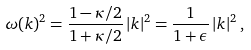<formula> <loc_0><loc_0><loc_500><loc_500>\omega ( { k } ) ^ { 2 } = \frac { 1 - \kappa / 2 } { 1 + \kappa / 2 } \, | { k } | ^ { 2 } = \frac { 1 } { 1 + \epsilon } \, | { k } | ^ { 2 } \, ,</formula> 